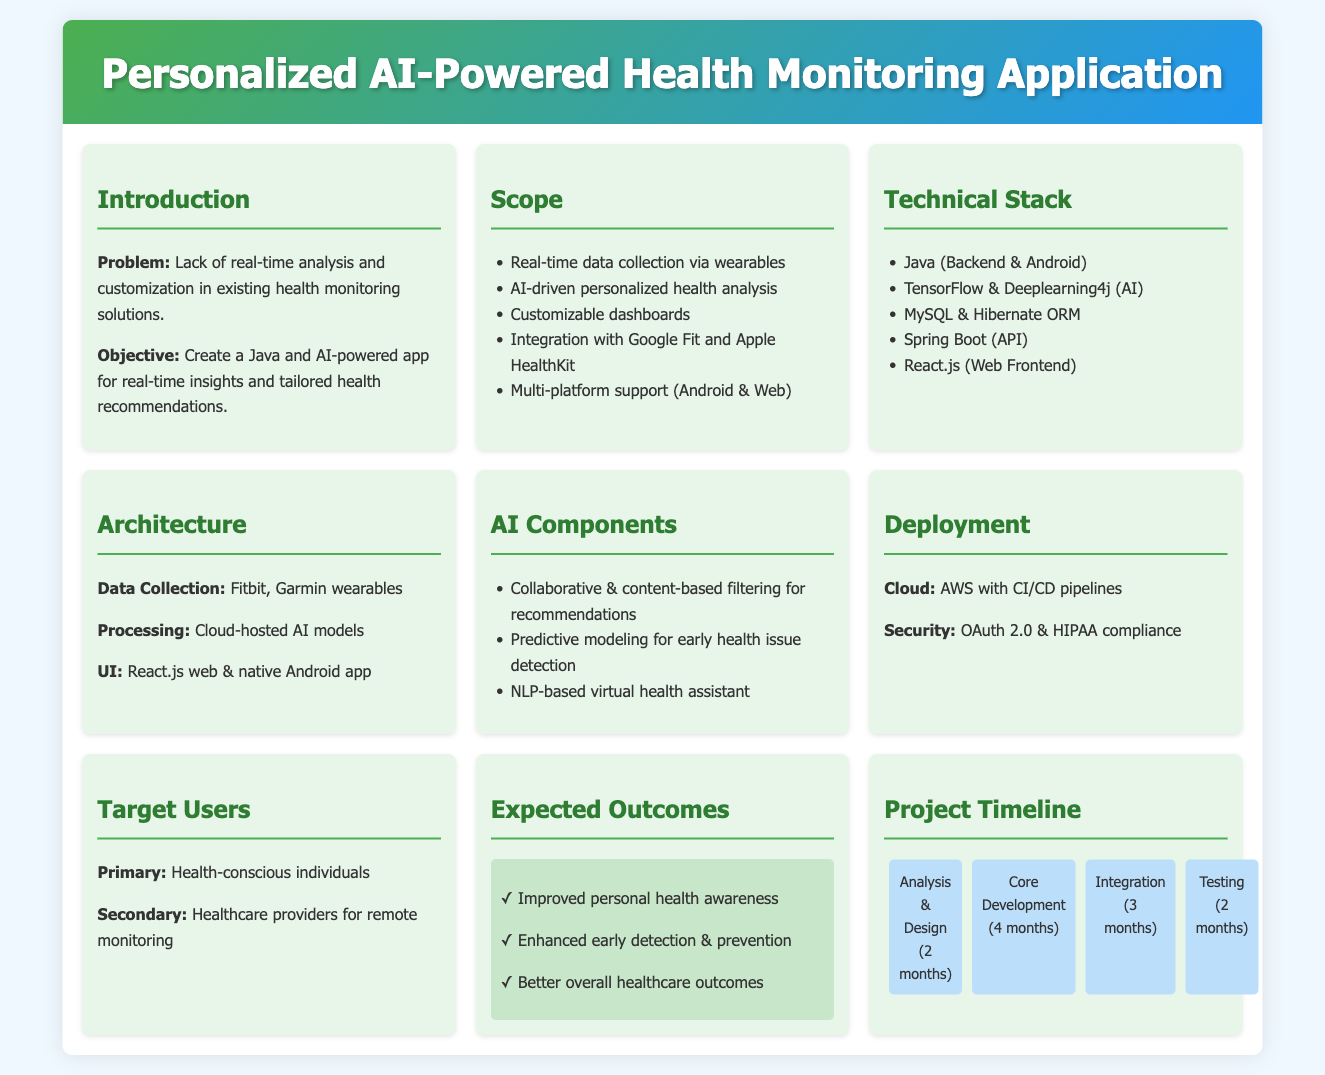What is the primary problem addressed by the app? The app addresses the lack of real-time analysis and customization in existing health monitoring solutions.
Answer: Lack of real-time analysis and customization What is the development language used for the app? The development language mentioned for the app is Java.
Answer: Java How many months is the core development phase planned to take? The core development phase is planned to last for 4 months.
Answer: 4 months What type of analysis uses predictive modeling in the app? Predictive modeling is used for early health issue detection.
Answer: Early health issue detection Which platforms will the personalized health monitoring app support? The app will support Android and Web platforms.
Answer: Android & Web What is the cloud service provider mentioned for deployment? The cloud service provider mentioned for deployment is AWS.
Answer: AWS What is the expected outcome related to health awareness? The expected outcome is improved personal health awareness.
Answer: Improved personal health awareness What is the analysis and design phase duration? The analysis and design phase is set for 2 months.
Answer: 2 months Who are the primary target users of the app? The primary target users are health-conscious individuals.
Answer: Health-conscious individuals 